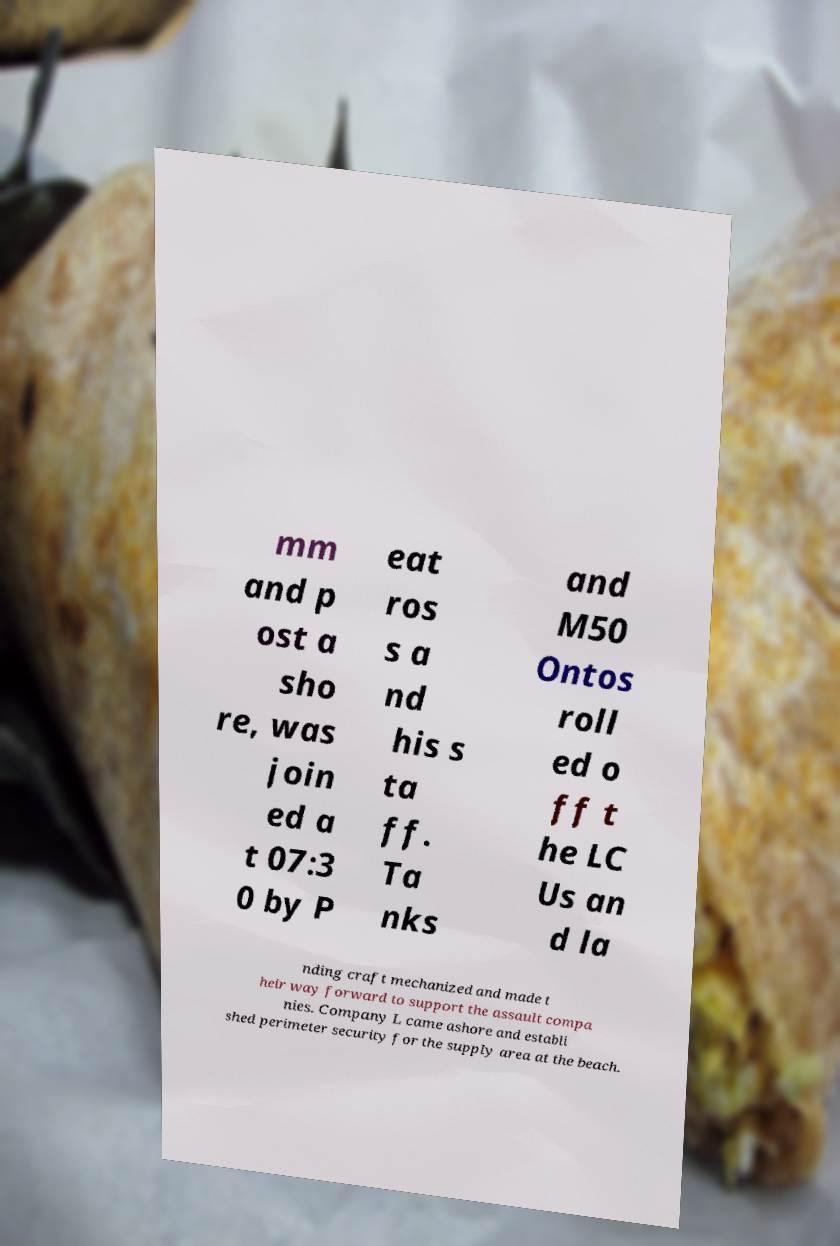Please identify and transcribe the text found in this image. mm and p ost a sho re, was join ed a t 07:3 0 by P eat ros s a nd his s ta ff. Ta nks and M50 Ontos roll ed o ff t he LC Us an d la nding craft mechanized and made t heir way forward to support the assault compa nies. Company L came ashore and establi shed perimeter security for the supply area at the beach. 